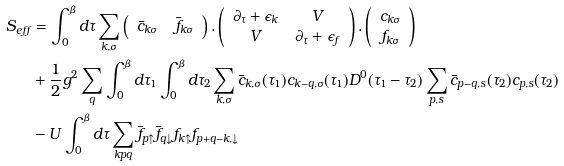<formula> <loc_0><loc_0><loc_500><loc_500>S _ { e f f } & = \int _ { 0 } ^ { \beta } d \tau \sum _ { k , \sigma } \left ( \begin{array} { c c } \bar { c } _ { k \sigma } & \bar { f } _ { k \sigma } \\ \end{array} \right ) . \left ( \begin{array} { c c } \partial _ { \tau } + \epsilon _ { k } & V \\ V & \partial _ { \tau } + \epsilon _ { f } \\ \end{array} \right ) . \left ( \begin{array} { c } c _ { k \sigma } \\ f _ { k \sigma } \\ \end{array} \right ) \\ & + \frac { 1 } { 2 } g ^ { 2 } \sum _ { q } \int _ { 0 } ^ { \beta } d \tau _ { 1 } \int _ { 0 } ^ { \beta } d \tau _ { 2 } \sum _ { k , \sigma } \bar { c } _ { k , \sigma } ( \tau _ { 1 } ) c _ { k - q , \sigma } ( \tau _ { 1 } ) D ^ { 0 } ( \tau _ { 1 } - \tau _ { 2 } ) \sum _ { p , s } \bar { c } _ { p - q , s } ( \tau _ { 2 } ) c _ { p , s } ( \tau _ { 2 } ) \\ & - U \int _ { 0 } ^ { \beta } d \tau \sum _ { k p q } \bar { f } _ { p \uparrow } \bar { f } _ { q \downarrow } f _ { k \uparrow } f _ { p + q - k , \downarrow }</formula> 